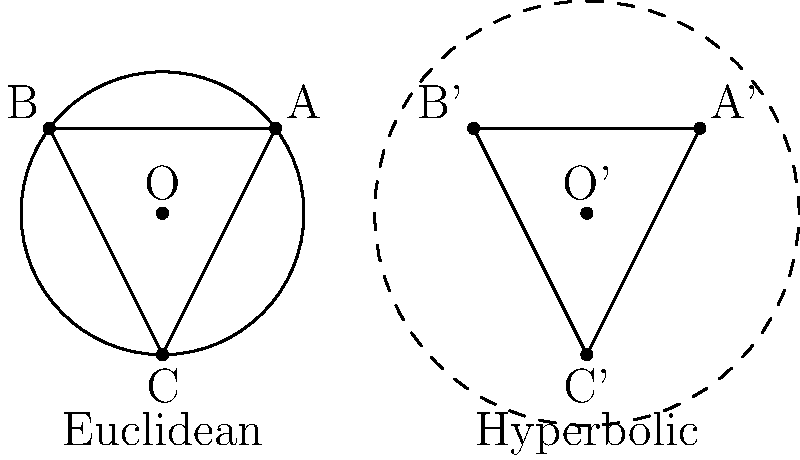In the diagram, we have two geometric models: Euclidean (left) and hyperbolic (right). Both show a circle with inscribed triangle ABC. In the Euclidean model, the sum of the interior angles of triangle ABC is 180°. How does the sum of the interior angles of triangle A'B'C' in the hyperbolic model compare to this? To understand the difference between Euclidean and hyperbolic geometry in this context, let's follow these steps:

1) In Euclidean geometry:
   - The sum of interior angles of any triangle is always 180°.
   - This is true regardless of the triangle's size or shape.

2) In hyperbolic geometry:
   - The sum of interior angles of a triangle is always less than 180°.
   - This is a fundamental property of hyperbolic space.

3) Why this difference occurs:
   - In Euclidean space, parallel lines remain equidistant.
   - In hyperbolic space, parallel lines diverge from each other.
   - This causes the angles in hyperbolic triangles to be "smaller" than their Euclidean counterparts.

4) The effect on the inscribed triangle:
   - In the Euclidean model, triangle ABC has a sum of interior angles equal to 180°.
   - In the hyperbolic model, triangle A'B'C' will have a sum of interior angles less than 180°.

5) The exact value:
   - The specific sum depends on the size of the triangle in hyperbolic space.
   - Larger triangles will have a smaller sum of interior angles.
   - As triangles approach infinitesimal size, their angle sum approaches 180°.

Therefore, in the hyperbolic model, the sum of interior angles of triangle A'B'C' will be less than 180°, demonstrating a key difference between Euclidean and hyperbolic geometry.
Answer: Less than 180° 